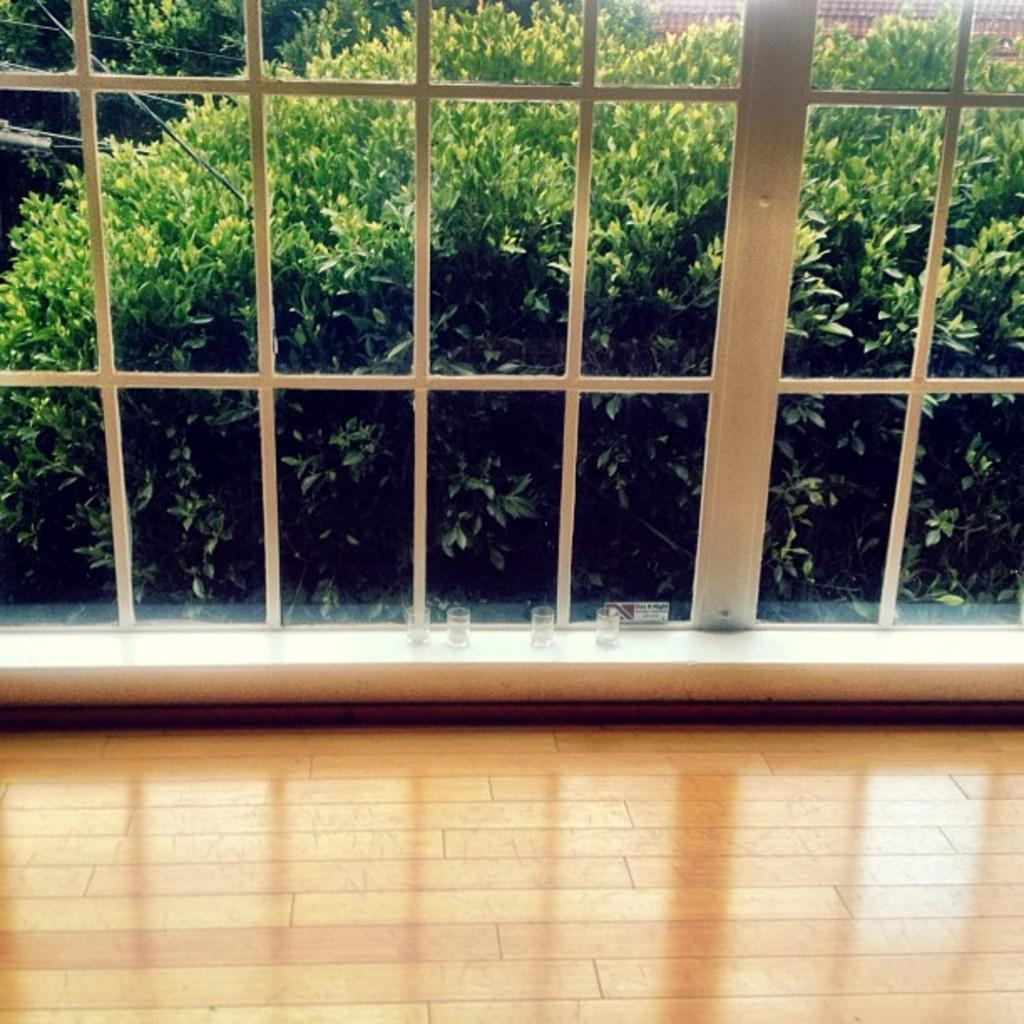What is located in the center of the image? There is a window in the center of the image. What can be seen through the window? Bushes are visible through the window. What type of meat can be seen hanging in the market in the image? There is no market or meat present in the image; it only features a window with bushes visible through it. 